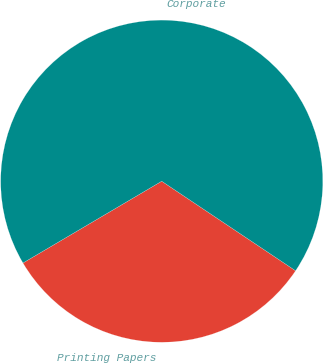Convert chart. <chart><loc_0><loc_0><loc_500><loc_500><pie_chart><fcel>Printing Papers<fcel>Corporate<nl><fcel>32.14%<fcel>67.86%<nl></chart> 